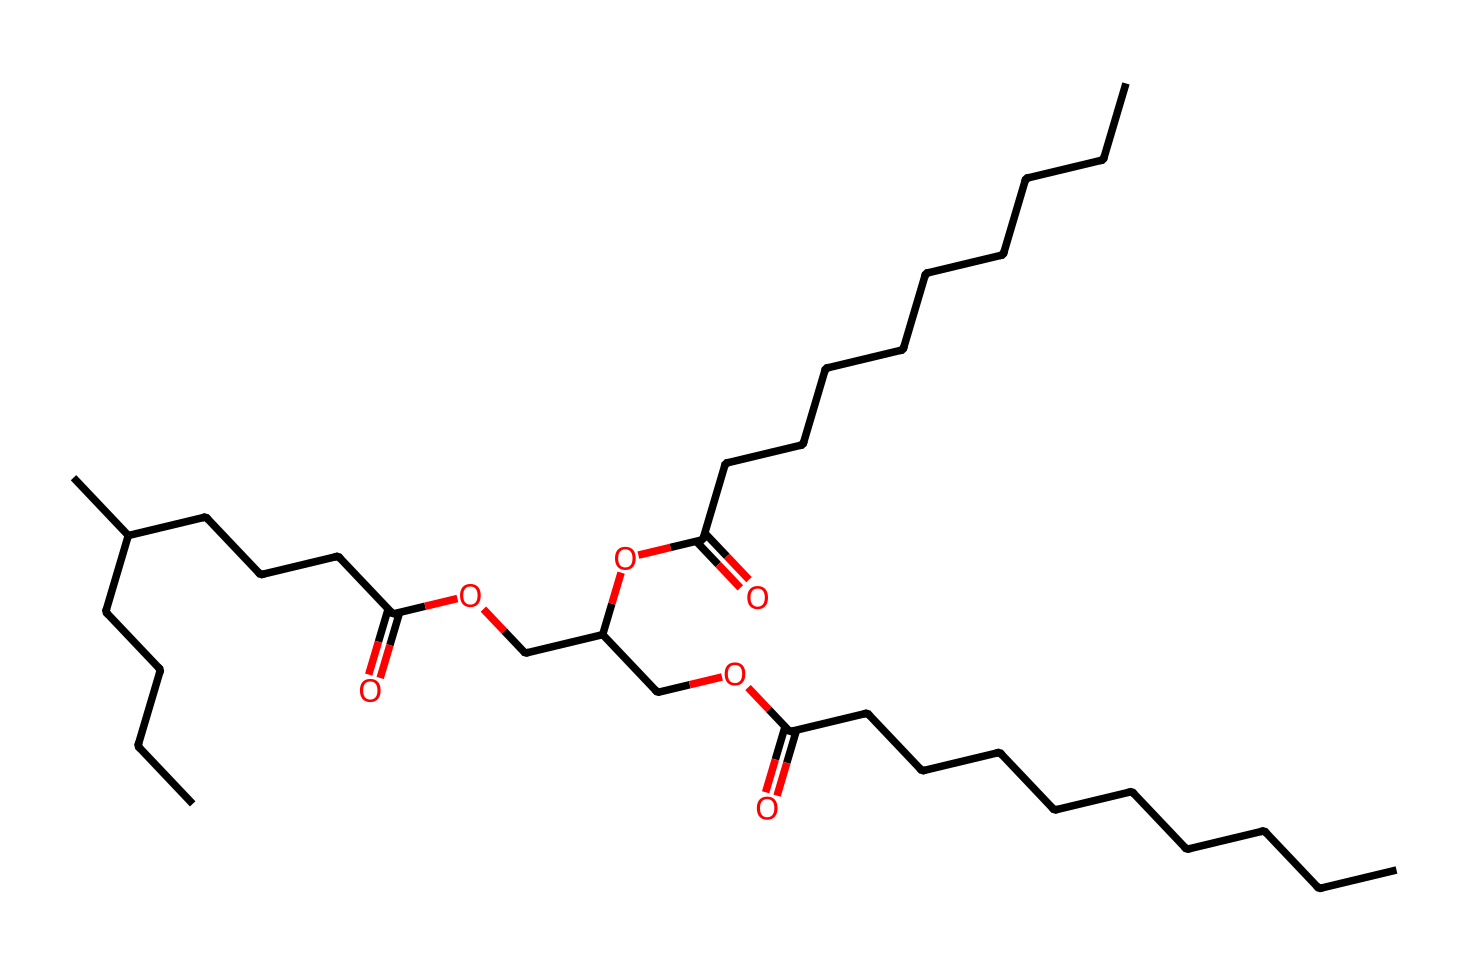What is the main functional group present in this chemical? The provided SMILES indicates the presence of several carboxylic acid groups denoted by the "(=O)O" component attached to carbon chains. These functional groups are characteristic of triglycerides.
Answer: carboxylic acid How many carbon atoms are present in this structure? By counting the carbon atoms in the chains represented in the SMILES notation, it can be determined that there are 30 carbon atoms total, which includes the carbon in the backbone and the terminal groups.
Answer: 30 What type of lipid is represented by this chemical? The structure represents a triglyceride, which consists of glycerol combined with three fatty acid chains (as seen in the long carbon chains attached to the glycerol backbone structure).
Answer: triglyceride How many ester bonds are present in this triglyceride? In the structure, each fatty acid chain is linked to the glycerol backbone via an ester bond. The molecule reveals three ester bonds corresponding to the three fatty acid attachments.
Answer: 3 Does this chemical structure indicate natural or synthetic triglycerides? The presence of long-chain fatty acids and the complexity of the structure suggests that this may be a synthetic triglyceride, often found in processed food products, which can differ from natural ones.
Answer: synthetic 